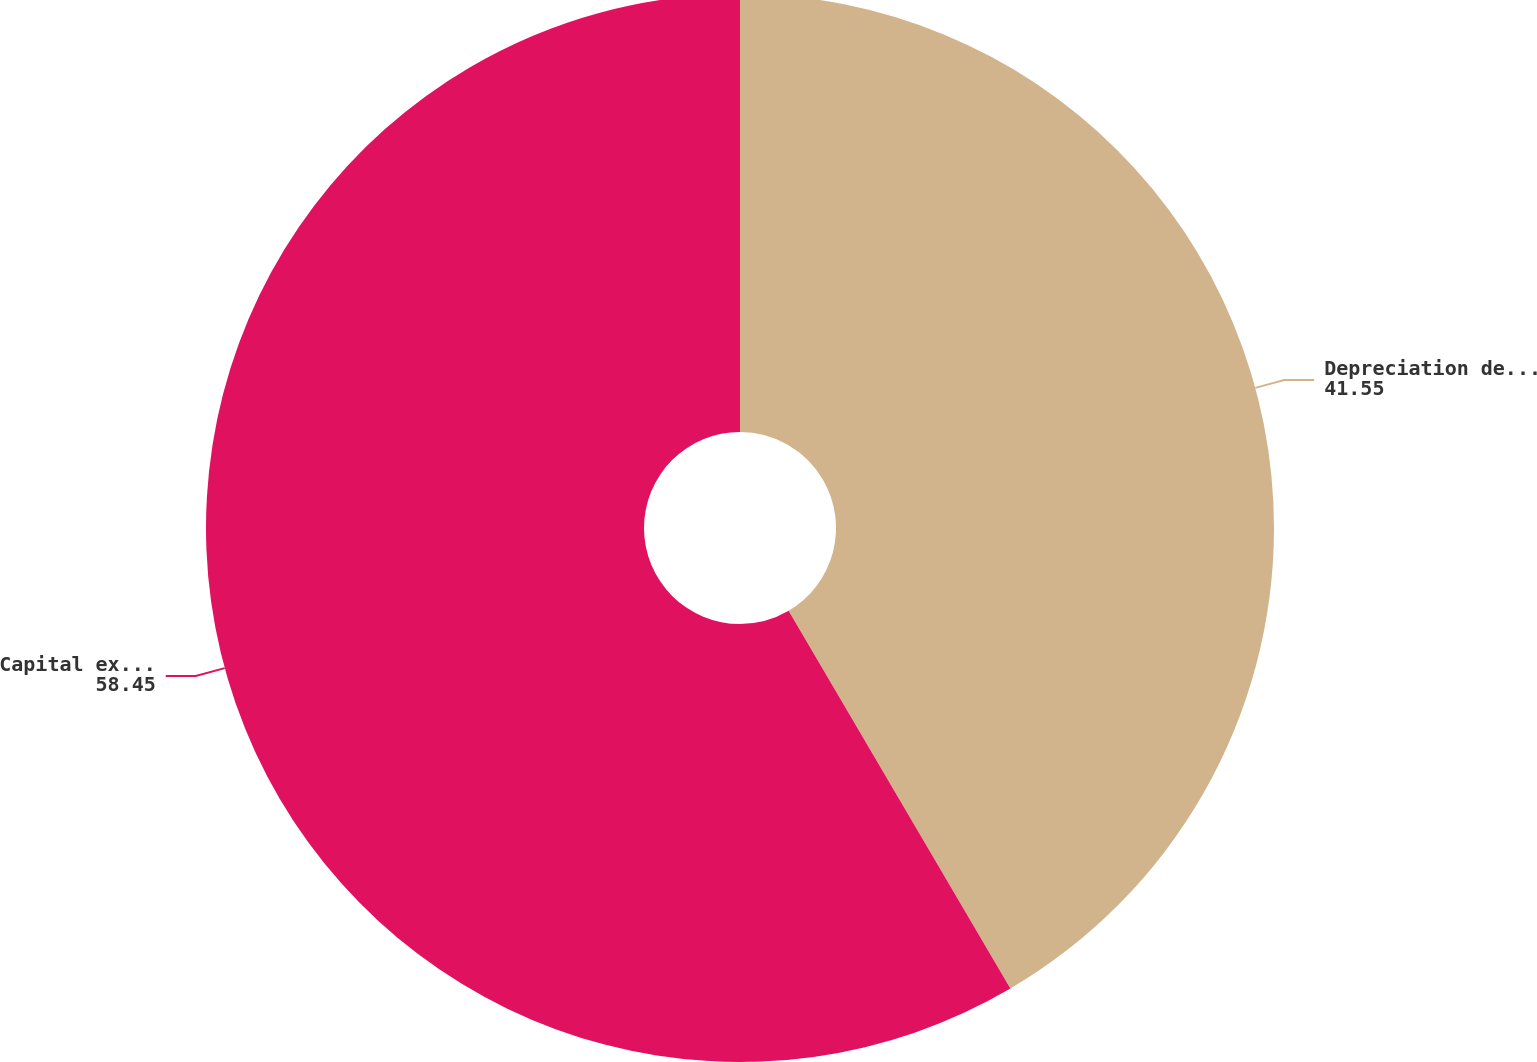<chart> <loc_0><loc_0><loc_500><loc_500><pie_chart><fcel>Depreciation depletion and<fcel>Capital expenditures<nl><fcel>41.55%<fcel>58.45%<nl></chart> 